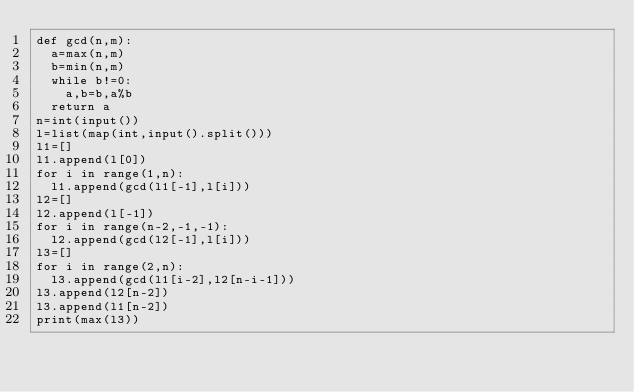<code> <loc_0><loc_0><loc_500><loc_500><_Python_>def gcd(n,m):
  a=max(n,m)
  b=min(n,m)
  while b!=0:
    a,b=b,a%b
  return a
n=int(input())
l=list(map(int,input().split()))
l1=[]
l1.append(l[0])
for i in range(1,n):
  l1.append(gcd(l1[-1],l[i]))
l2=[]
l2.append(l[-1])
for i in range(n-2,-1,-1):
  l2.append(gcd(l2[-1],l[i]))
l3=[]
for i in range(2,n):
  l3.append(gcd(l1[i-2],l2[n-i-1]))
l3.append(l2[n-2])
l3.append(l1[n-2])
print(max(l3))
            
                

</code> 